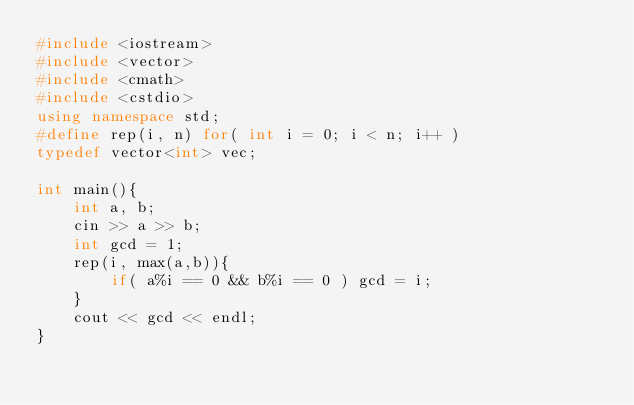Convert code to text. <code><loc_0><loc_0><loc_500><loc_500><_C++_>#include <iostream>
#include <vector>
#include <cmath>
#include <cstdio>
using namespace std;
#define rep(i, n) for( int i = 0; i < n; i++ )
typedef vector<int> vec;

int main(){
    int a, b;
    cin >> a >> b;
    int gcd = 1;
    rep(i, max(a,b)){
        if( a%i == 0 && b%i == 0 ) gcd = i;
    }
    cout << gcd << endl;
}</code> 